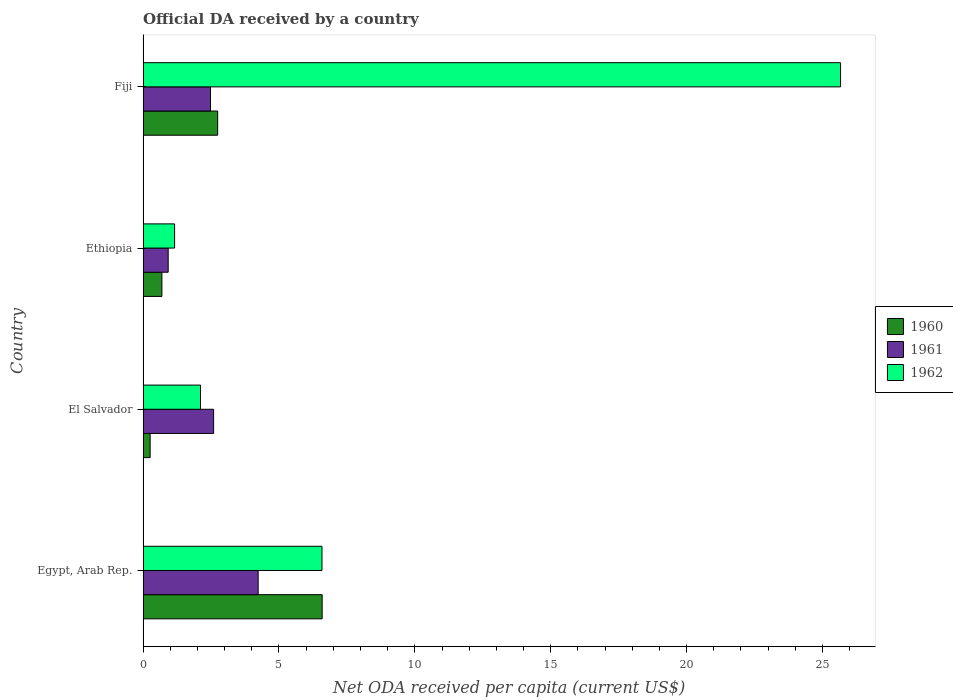How many different coloured bars are there?
Offer a very short reply. 3. Are the number of bars per tick equal to the number of legend labels?
Give a very brief answer. Yes. Are the number of bars on each tick of the Y-axis equal?
Provide a succinct answer. Yes. How many bars are there on the 3rd tick from the top?
Your answer should be compact. 3. What is the label of the 1st group of bars from the top?
Your response must be concise. Fiji. What is the ODA received in in 1960 in El Salvador?
Your answer should be compact. 0.26. Across all countries, what is the maximum ODA received in in 1961?
Offer a very short reply. 4.23. Across all countries, what is the minimum ODA received in in 1961?
Give a very brief answer. 0.92. In which country was the ODA received in in 1960 maximum?
Provide a short and direct response. Egypt, Arab Rep. In which country was the ODA received in in 1961 minimum?
Your answer should be very brief. Ethiopia. What is the total ODA received in in 1961 in the graph?
Offer a very short reply. 10.24. What is the difference between the ODA received in in 1961 in Egypt, Arab Rep. and that in Ethiopia?
Ensure brevity in your answer.  3.31. What is the difference between the ODA received in in 1962 in El Salvador and the ODA received in in 1960 in Egypt, Arab Rep.?
Offer a very short reply. -4.48. What is the average ODA received in in 1961 per country?
Make the answer very short. 2.56. What is the difference between the ODA received in in 1962 and ODA received in in 1960 in Fiji?
Make the answer very short. 22.92. What is the ratio of the ODA received in in 1960 in Egypt, Arab Rep. to that in Fiji?
Ensure brevity in your answer.  2.4. Is the ODA received in in 1962 in Egypt, Arab Rep. less than that in Ethiopia?
Your answer should be very brief. No. Is the difference between the ODA received in in 1962 in Egypt, Arab Rep. and Fiji greater than the difference between the ODA received in in 1960 in Egypt, Arab Rep. and Fiji?
Give a very brief answer. No. What is the difference between the highest and the second highest ODA received in in 1962?
Your answer should be very brief. 19.08. What is the difference between the highest and the lowest ODA received in in 1962?
Ensure brevity in your answer.  24.51. In how many countries, is the ODA received in in 1962 greater than the average ODA received in in 1962 taken over all countries?
Keep it short and to the point. 1. What does the 1st bar from the bottom in Fiji represents?
Make the answer very short. 1960. Are all the bars in the graph horizontal?
Offer a very short reply. Yes. How many countries are there in the graph?
Ensure brevity in your answer.  4. What is the difference between two consecutive major ticks on the X-axis?
Your response must be concise. 5. Does the graph contain any zero values?
Keep it short and to the point. No. Does the graph contain grids?
Your answer should be compact. No. What is the title of the graph?
Offer a very short reply. Official DA received by a country. What is the label or title of the X-axis?
Keep it short and to the point. Net ODA received per capita (current US$). What is the label or title of the Y-axis?
Your response must be concise. Country. What is the Net ODA received per capita (current US$) in 1960 in Egypt, Arab Rep.?
Keep it short and to the point. 6.59. What is the Net ODA received per capita (current US$) of 1961 in Egypt, Arab Rep.?
Your answer should be very brief. 4.23. What is the Net ODA received per capita (current US$) of 1962 in Egypt, Arab Rep.?
Your answer should be very brief. 6.58. What is the Net ODA received per capita (current US$) of 1960 in El Salvador?
Keep it short and to the point. 0.26. What is the Net ODA received per capita (current US$) in 1961 in El Salvador?
Make the answer very short. 2.6. What is the Net ODA received per capita (current US$) of 1962 in El Salvador?
Ensure brevity in your answer.  2.11. What is the Net ODA received per capita (current US$) in 1960 in Ethiopia?
Keep it short and to the point. 0.69. What is the Net ODA received per capita (current US$) of 1961 in Ethiopia?
Provide a succinct answer. 0.92. What is the Net ODA received per capita (current US$) in 1962 in Ethiopia?
Make the answer very short. 1.16. What is the Net ODA received per capita (current US$) in 1960 in Fiji?
Your answer should be very brief. 2.75. What is the Net ODA received per capita (current US$) in 1961 in Fiji?
Give a very brief answer. 2.48. What is the Net ODA received per capita (current US$) of 1962 in Fiji?
Your answer should be very brief. 25.67. Across all countries, what is the maximum Net ODA received per capita (current US$) in 1960?
Your response must be concise. 6.59. Across all countries, what is the maximum Net ODA received per capita (current US$) in 1961?
Provide a short and direct response. 4.23. Across all countries, what is the maximum Net ODA received per capita (current US$) of 1962?
Offer a terse response. 25.67. Across all countries, what is the minimum Net ODA received per capita (current US$) in 1960?
Offer a terse response. 0.26. Across all countries, what is the minimum Net ODA received per capita (current US$) in 1961?
Provide a succinct answer. 0.92. Across all countries, what is the minimum Net ODA received per capita (current US$) in 1962?
Your response must be concise. 1.16. What is the total Net ODA received per capita (current US$) in 1960 in the graph?
Your answer should be compact. 10.29. What is the total Net ODA received per capita (current US$) of 1961 in the graph?
Provide a short and direct response. 10.24. What is the total Net ODA received per capita (current US$) in 1962 in the graph?
Keep it short and to the point. 35.52. What is the difference between the Net ODA received per capita (current US$) of 1960 in Egypt, Arab Rep. and that in El Salvador?
Your answer should be very brief. 6.33. What is the difference between the Net ODA received per capita (current US$) in 1961 in Egypt, Arab Rep. and that in El Salvador?
Offer a very short reply. 1.64. What is the difference between the Net ODA received per capita (current US$) in 1962 in Egypt, Arab Rep. and that in El Salvador?
Your response must be concise. 4.47. What is the difference between the Net ODA received per capita (current US$) in 1960 in Egypt, Arab Rep. and that in Ethiopia?
Your response must be concise. 5.9. What is the difference between the Net ODA received per capita (current US$) of 1961 in Egypt, Arab Rep. and that in Ethiopia?
Your answer should be very brief. 3.31. What is the difference between the Net ODA received per capita (current US$) of 1962 in Egypt, Arab Rep. and that in Ethiopia?
Provide a succinct answer. 5.42. What is the difference between the Net ODA received per capita (current US$) in 1960 in Egypt, Arab Rep. and that in Fiji?
Your answer should be compact. 3.84. What is the difference between the Net ODA received per capita (current US$) of 1961 in Egypt, Arab Rep. and that in Fiji?
Make the answer very short. 1.75. What is the difference between the Net ODA received per capita (current US$) in 1962 in Egypt, Arab Rep. and that in Fiji?
Provide a short and direct response. -19.08. What is the difference between the Net ODA received per capita (current US$) in 1960 in El Salvador and that in Ethiopia?
Provide a short and direct response. -0.43. What is the difference between the Net ODA received per capita (current US$) in 1961 in El Salvador and that in Ethiopia?
Make the answer very short. 1.67. What is the difference between the Net ODA received per capita (current US$) in 1962 in El Salvador and that in Ethiopia?
Your answer should be very brief. 0.95. What is the difference between the Net ODA received per capita (current US$) in 1960 in El Salvador and that in Fiji?
Make the answer very short. -2.48. What is the difference between the Net ODA received per capita (current US$) of 1961 in El Salvador and that in Fiji?
Your answer should be compact. 0.12. What is the difference between the Net ODA received per capita (current US$) of 1962 in El Salvador and that in Fiji?
Give a very brief answer. -23.55. What is the difference between the Net ODA received per capita (current US$) in 1960 in Ethiopia and that in Fiji?
Your response must be concise. -2.05. What is the difference between the Net ODA received per capita (current US$) of 1961 in Ethiopia and that in Fiji?
Make the answer very short. -1.56. What is the difference between the Net ODA received per capita (current US$) of 1962 in Ethiopia and that in Fiji?
Make the answer very short. -24.51. What is the difference between the Net ODA received per capita (current US$) of 1960 in Egypt, Arab Rep. and the Net ODA received per capita (current US$) of 1961 in El Salvador?
Provide a short and direct response. 3.99. What is the difference between the Net ODA received per capita (current US$) in 1960 in Egypt, Arab Rep. and the Net ODA received per capita (current US$) in 1962 in El Salvador?
Offer a very short reply. 4.48. What is the difference between the Net ODA received per capita (current US$) of 1961 in Egypt, Arab Rep. and the Net ODA received per capita (current US$) of 1962 in El Salvador?
Offer a very short reply. 2.12. What is the difference between the Net ODA received per capita (current US$) in 1960 in Egypt, Arab Rep. and the Net ODA received per capita (current US$) in 1961 in Ethiopia?
Provide a succinct answer. 5.67. What is the difference between the Net ODA received per capita (current US$) of 1960 in Egypt, Arab Rep. and the Net ODA received per capita (current US$) of 1962 in Ethiopia?
Ensure brevity in your answer.  5.43. What is the difference between the Net ODA received per capita (current US$) in 1961 in Egypt, Arab Rep. and the Net ODA received per capita (current US$) in 1962 in Ethiopia?
Keep it short and to the point. 3.07. What is the difference between the Net ODA received per capita (current US$) in 1960 in Egypt, Arab Rep. and the Net ODA received per capita (current US$) in 1961 in Fiji?
Make the answer very short. 4.11. What is the difference between the Net ODA received per capita (current US$) in 1960 in Egypt, Arab Rep. and the Net ODA received per capita (current US$) in 1962 in Fiji?
Your response must be concise. -19.08. What is the difference between the Net ODA received per capita (current US$) in 1961 in Egypt, Arab Rep. and the Net ODA received per capita (current US$) in 1962 in Fiji?
Your answer should be very brief. -21.43. What is the difference between the Net ODA received per capita (current US$) in 1960 in El Salvador and the Net ODA received per capita (current US$) in 1961 in Ethiopia?
Provide a succinct answer. -0.66. What is the difference between the Net ODA received per capita (current US$) in 1960 in El Salvador and the Net ODA received per capita (current US$) in 1962 in Ethiopia?
Offer a very short reply. -0.9. What is the difference between the Net ODA received per capita (current US$) in 1961 in El Salvador and the Net ODA received per capita (current US$) in 1962 in Ethiopia?
Give a very brief answer. 1.44. What is the difference between the Net ODA received per capita (current US$) of 1960 in El Salvador and the Net ODA received per capita (current US$) of 1961 in Fiji?
Offer a very short reply. -2.22. What is the difference between the Net ODA received per capita (current US$) in 1960 in El Salvador and the Net ODA received per capita (current US$) in 1962 in Fiji?
Keep it short and to the point. -25.41. What is the difference between the Net ODA received per capita (current US$) of 1961 in El Salvador and the Net ODA received per capita (current US$) of 1962 in Fiji?
Give a very brief answer. -23.07. What is the difference between the Net ODA received per capita (current US$) in 1960 in Ethiopia and the Net ODA received per capita (current US$) in 1961 in Fiji?
Provide a succinct answer. -1.79. What is the difference between the Net ODA received per capita (current US$) in 1960 in Ethiopia and the Net ODA received per capita (current US$) in 1962 in Fiji?
Offer a very short reply. -24.97. What is the difference between the Net ODA received per capita (current US$) in 1961 in Ethiopia and the Net ODA received per capita (current US$) in 1962 in Fiji?
Provide a short and direct response. -24.74. What is the average Net ODA received per capita (current US$) in 1960 per country?
Your answer should be compact. 2.57. What is the average Net ODA received per capita (current US$) of 1961 per country?
Your answer should be very brief. 2.56. What is the average Net ODA received per capita (current US$) of 1962 per country?
Provide a succinct answer. 8.88. What is the difference between the Net ODA received per capita (current US$) of 1960 and Net ODA received per capita (current US$) of 1961 in Egypt, Arab Rep.?
Make the answer very short. 2.36. What is the difference between the Net ODA received per capita (current US$) of 1960 and Net ODA received per capita (current US$) of 1962 in Egypt, Arab Rep.?
Provide a short and direct response. 0.01. What is the difference between the Net ODA received per capita (current US$) of 1961 and Net ODA received per capita (current US$) of 1962 in Egypt, Arab Rep.?
Keep it short and to the point. -2.35. What is the difference between the Net ODA received per capita (current US$) in 1960 and Net ODA received per capita (current US$) in 1961 in El Salvador?
Provide a short and direct response. -2.33. What is the difference between the Net ODA received per capita (current US$) of 1960 and Net ODA received per capita (current US$) of 1962 in El Salvador?
Keep it short and to the point. -1.85. What is the difference between the Net ODA received per capita (current US$) in 1961 and Net ODA received per capita (current US$) in 1962 in El Salvador?
Make the answer very short. 0.48. What is the difference between the Net ODA received per capita (current US$) of 1960 and Net ODA received per capita (current US$) of 1961 in Ethiopia?
Your response must be concise. -0.23. What is the difference between the Net ODA received per capita (current US$) in 1960 and Net ODA received per capita (current US$) in 1962 in Ethiopia?
Offer a very short reply. -0.47. What is the difference between the Net ODA received per capita (current US$) of 1961 and Net ODA received per capita (current US$) of 1962 in Ethiopia?
Your response must be concise. -0.24. What is the difference between the Net ODA received per capita (current US$) of 1960 and Net ODA received per capita (current US$) of 1961 in Fiji?
Ensure brevity in your answer.  0.26. What is the difference between the Net ODA received per capita (current US$) in 1960 and Net ODA received per capita (current US$) in 1962 in Fiji?
Offer a terse response. -22.92. What is the difference between the Net ODA received per capita (current US$) of 1961 and Net ODA received per capita (current US$) of 1962 in Fiji?
Make the answer very short. -23.18. What is the ratio of the Net ODA received per capita (current US$) in 1960 in Egypt, Arab Rep. to that in El Salvador?
Your answer should be compact. 25.29. What is the ratio of the Net ODA received per capita (current US$) in 1961 in Egypt, Arab Rep. to that in El Salvador?
Provide a succinct answer. 1.63. What is the ratio of the Net ODA received per capita (current US$) in 1962 in Egypt, Arab Rep. to that in El Salvador?
Ensure brevity in your answer.  3.11. What is the ratio of the Net ODA received per capita (current US$) of 1960 in Egypt, Arab Rep. to that in Ethiopia?
Give a very brief answer. 9.51. What is the ratio of the Net ODA received per capita (current US$) in 1961 in Egypt, Arab Rep. to that in Ethiopia?
Ensure brevity in your answer.  4.58. What is the ratio of the Net ODA received per capita (current US$) of 1962 in Egypt, Arab Rep. to that in Ethiopia?
Provide a short and direct response. 5.68. What is the ratio of the Net ODA received per capita (current US$) in 1960 in Egypt, Arab Rep. to that in Fiji?
Provide a succinct answer. 2.4. What is the ratio of the Net ODA received per capita (current US$) in 1961 in Egypt, Arab Rep. to that in Fiji?
Your response must be concise. 1.71. What is the ratio of the Net ODA received per capita (current US$) of 1962 in Egypt, Arab Rep. to that in Fiji?
Provide a succinct answer. 0.26. What is the ratio of the Net ODA received per capita (current US$) of 1960 in El Salvador to that in Ethiopia?
Your response must be concise. 0.38. What is the ratio of the Net ODA received per capita (current US$) in 1961 in El Salvador to that in Ethiopia?
Make the answer very short. 2.81. What is the ratio of the Net ODA received per capita (current US$) of 1962 in El Salvador to that in Ethiopia?
Give a very brief answer. 1.82. What is the ratio of the Net ODA received per capita (current US$) of 1960 in El Salvador to that in Fiji?
Provide a short and direct response. 0.09. What is the ratio of the Net ODA received per capita (current US$) in 1961 in El Salvador to that in Fiji?
Provide a short and direct response. 1.05. What is the ratio of the Net ODA received per capita (current US$) of 1962 in El Salvador to that in Fiji?
Provide a succinct answer. 0.08. What is the ratio of the Net ODA received per capita (current US$) of 1960 in Ethiopia to that in Fiji?
Your answer should be very brief. 0.25. What is the ratio of the Net ODA received per capita (current US$) of 1961 in Ethiopia to that in Fiji?
Provide a succinct answer. 0.37. What is the ratio of the Net ODA received per capita (current US$) of 1962 in Ethiopia to that in Fiji?
Offer a very short reply. 0.05. What is the difference between the highest and the second highest Net ODA received per capita (current US$) of 1960?
Offer a very short reply. 3.84. What is the difference between the highest and the second highest Net ODA received per capita (current US$) in 1961?
Make the answer very short. 1.64. What is the difference between the highest and the second highest Net ODA received per capita (current US$) of 1962?
Keep it short and to the point. 19.08. What is the difference between the highest and the lowest Net ODA received per capita (current US$) in 1960?
Offer a very short reply. 6.33. What is the difference between the highest and the lowest Net ODA received per capita (current US$) of 1961?
Give a very brief answer. 3.31. What is the difference between the highest and the lowest Net ODA received per capita (current US$) in 1962?
Ensure brevity in your answer.  24.51. 